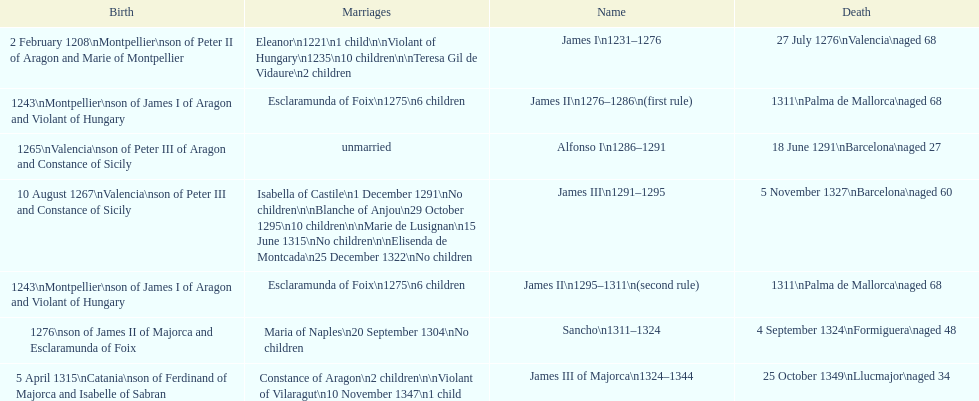What name is above james iii and below james ii? Alfonso I. 